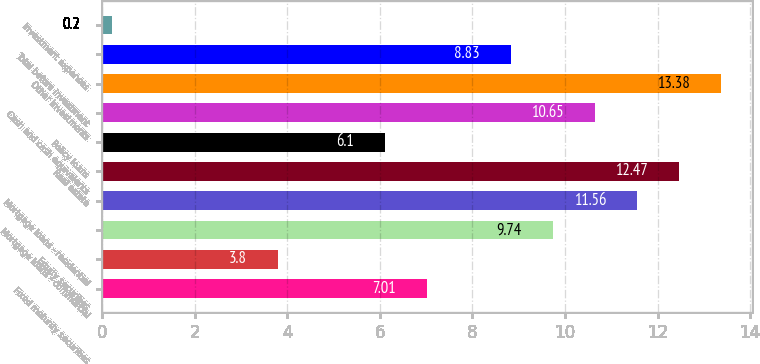Convert chart to OTSL. <chart><loc_0><loc_0><loc_500><loc_500><bar_chart><fcel>Fixed maturity securities<fcel>Equity securities<fcel>Mortgage loans - commercial<fcel>Mortgage loans - residential<fcel>Real estate<fcel>Policy loans<fcel>Cash and cash equivalents<fcel>Other investments<fcel>Total before investment<fcel>Investment expenses<nl><fcel>7.01<fcel>3.8<fcel>9.74<fcel>11.56<fcel>12.47<fcel>6.1<fcel>10.65<fcel>13.38<fcel>8.83<fcel>0.2<nl></chart> 